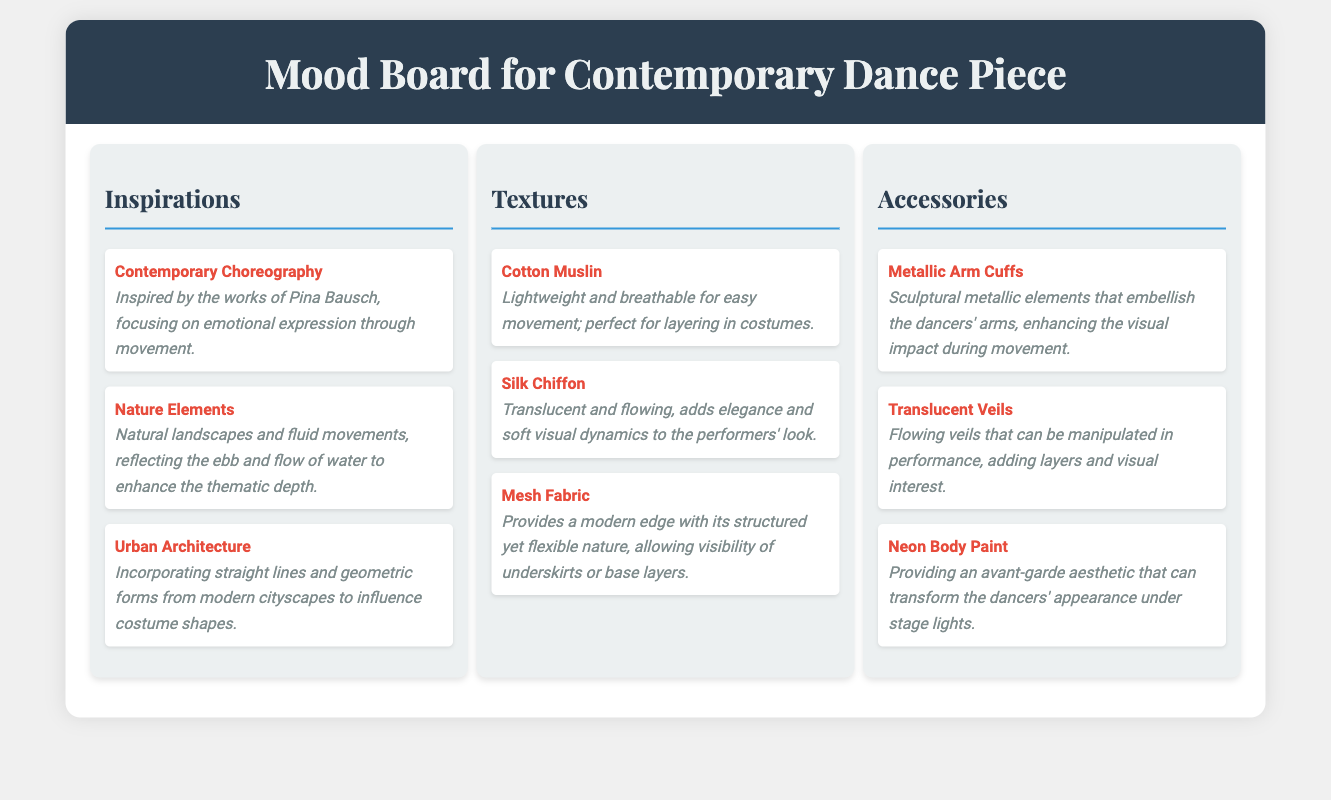What is the first inspiration listed? The first inspiration in the document is "Contemporary Choreography."
Answer: Contemporary Choreography How many textures are mentioned? The document lists three textures.
Answer: 3 What type of fabric is described as lightweight and breathable? The document specifies "Cotton Muslin" as lightweight and breathable.
Answer: Cotton Muslin What accessory adds layers and visual interest? "Translucent Veils" are mentioned as accessories that add layers and visual interest.
Answer: Translucent Veils Which choreographer's work inspires the emotional expression through movement? The document notes Pina Bausch as the choreographer inspiring emotional expression.
Answer: Pina Bausch What fabric is described as adding elegance to the performers' look? "Silk Chiffon" is stated to add elegance to the performers' look.
Answer: Silk Chiffon What color is the body paint mentioned? The body paint mentioned in the document is "Neon."
Answer: Neon What is a common theme among the inspirations? The inspirations focus on expressing emotions and connections to natural and urban environments.
Answer: Emotional expression How does mesh fabric enhance the costume? It provides a modern edge and allows visibility of underskirts.
Answer: Modern edge and visibility 